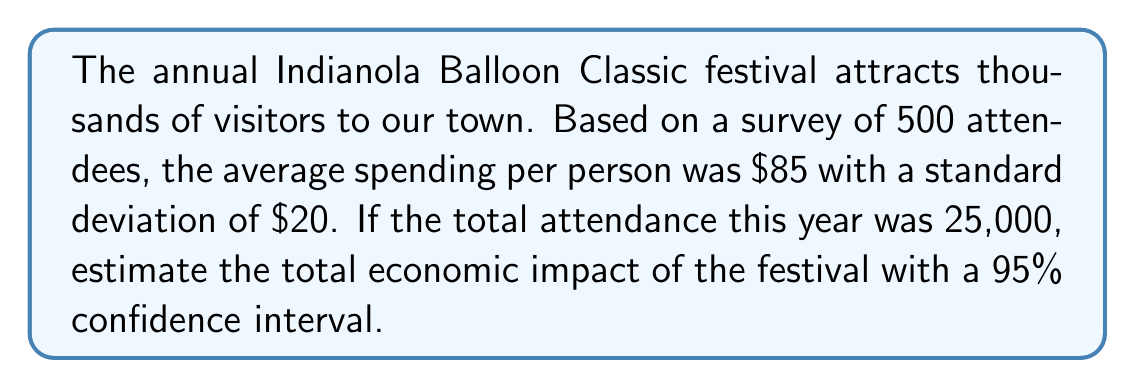Help me with this question. To estimate the economic impact with a 95% confidence interval, we'll follow these steps:

1) First, calculate the standard error of the mean:
   $SE = \frac{s}{\sqrt{n}} = \frac{20}{\sqrt{500}} = 0.894$

2) For a 95% confidence interval, we use a z-score of 1.96.

3) Calculate the margin of error:
   $ME = 1.96 * SE = 1.96 * 0.894 = 1.752$

4) The 95% confidence interval for the mean spending per person is:
   $85 \pm 1.752 = [83.248, 86.752]$

5) To estimate the total economic impact, multiply these bounds by the total attendance:
   Lower bound: $83.248 * 25,000 = 2,081,200$
   Upper bound: $86.752 * 25,000 = 2,168,800$

Therefore, we can estimate with 95% confidence that the total economic impact of the Indianola Balloon Classic festival is between $2,081,200 and $2,168,800.
Answer: [$2,081,200, $2,168,800] 